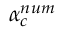<formula> <loc_0><loc_0><loc_500><loc_500>\alpha _ { c } ^ { n u m }</formula> 